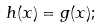<formula> <loc_0><loc_0><loc_500><loc_500>h ( x ) = g ( x ) ;</formula> 